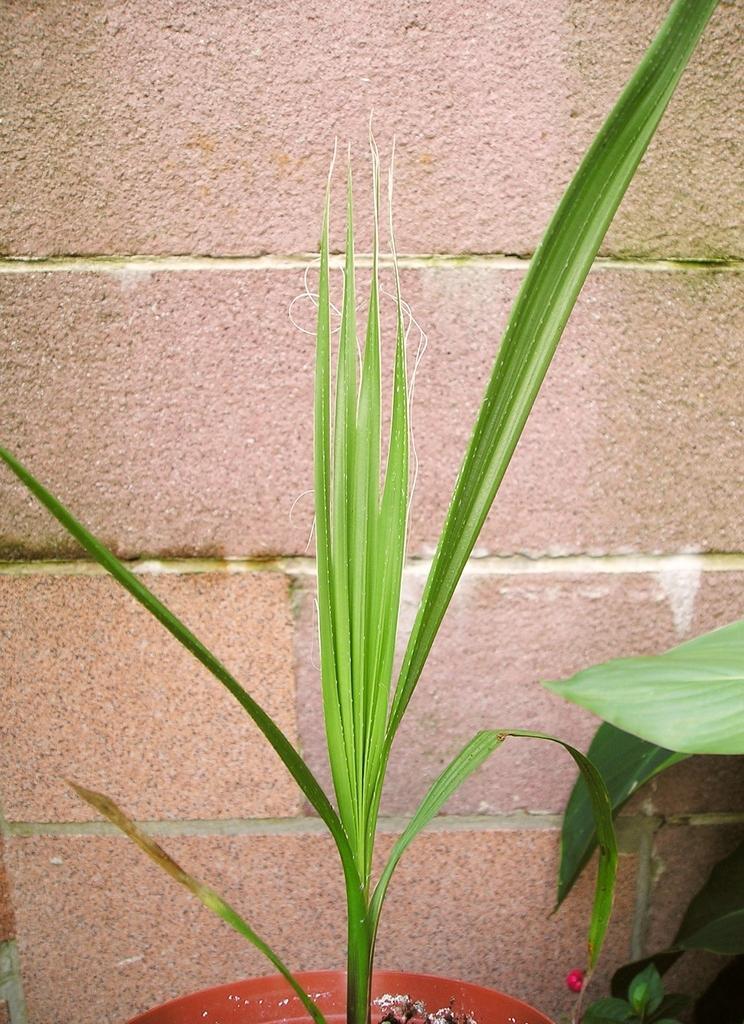In one or two sentences, can you explain what this image depicts? In this image I can see a potted plant in front of the wall. 